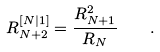<formula> <loc_0><loc_0><loc_500><loc_500>R _ { N + 2 } ^ { [ N | 1 ] } = \frac { R _ { N + 1 } ^ { 2 } } { R _ { N } } \quad .</formula> 